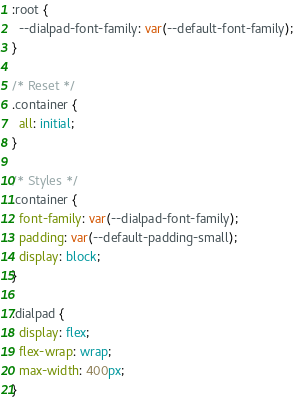Convert code to text. <code><loc_0><loc_0><loc_500><loc_500><_CSS_>
:root {
  --dialpad-font-family: var(--default-font-family);
}

/* Reset */
.container {
  all: initial;
}

/* Styles */
.container {
  font-family: var(--dialpad-font-family);
  padding: var(--default-padding-small);
  display: block;
}

.dialpad {
  display: flex;
  flex-wrap: wrap;
  max-width: 400px;
}
</code> 